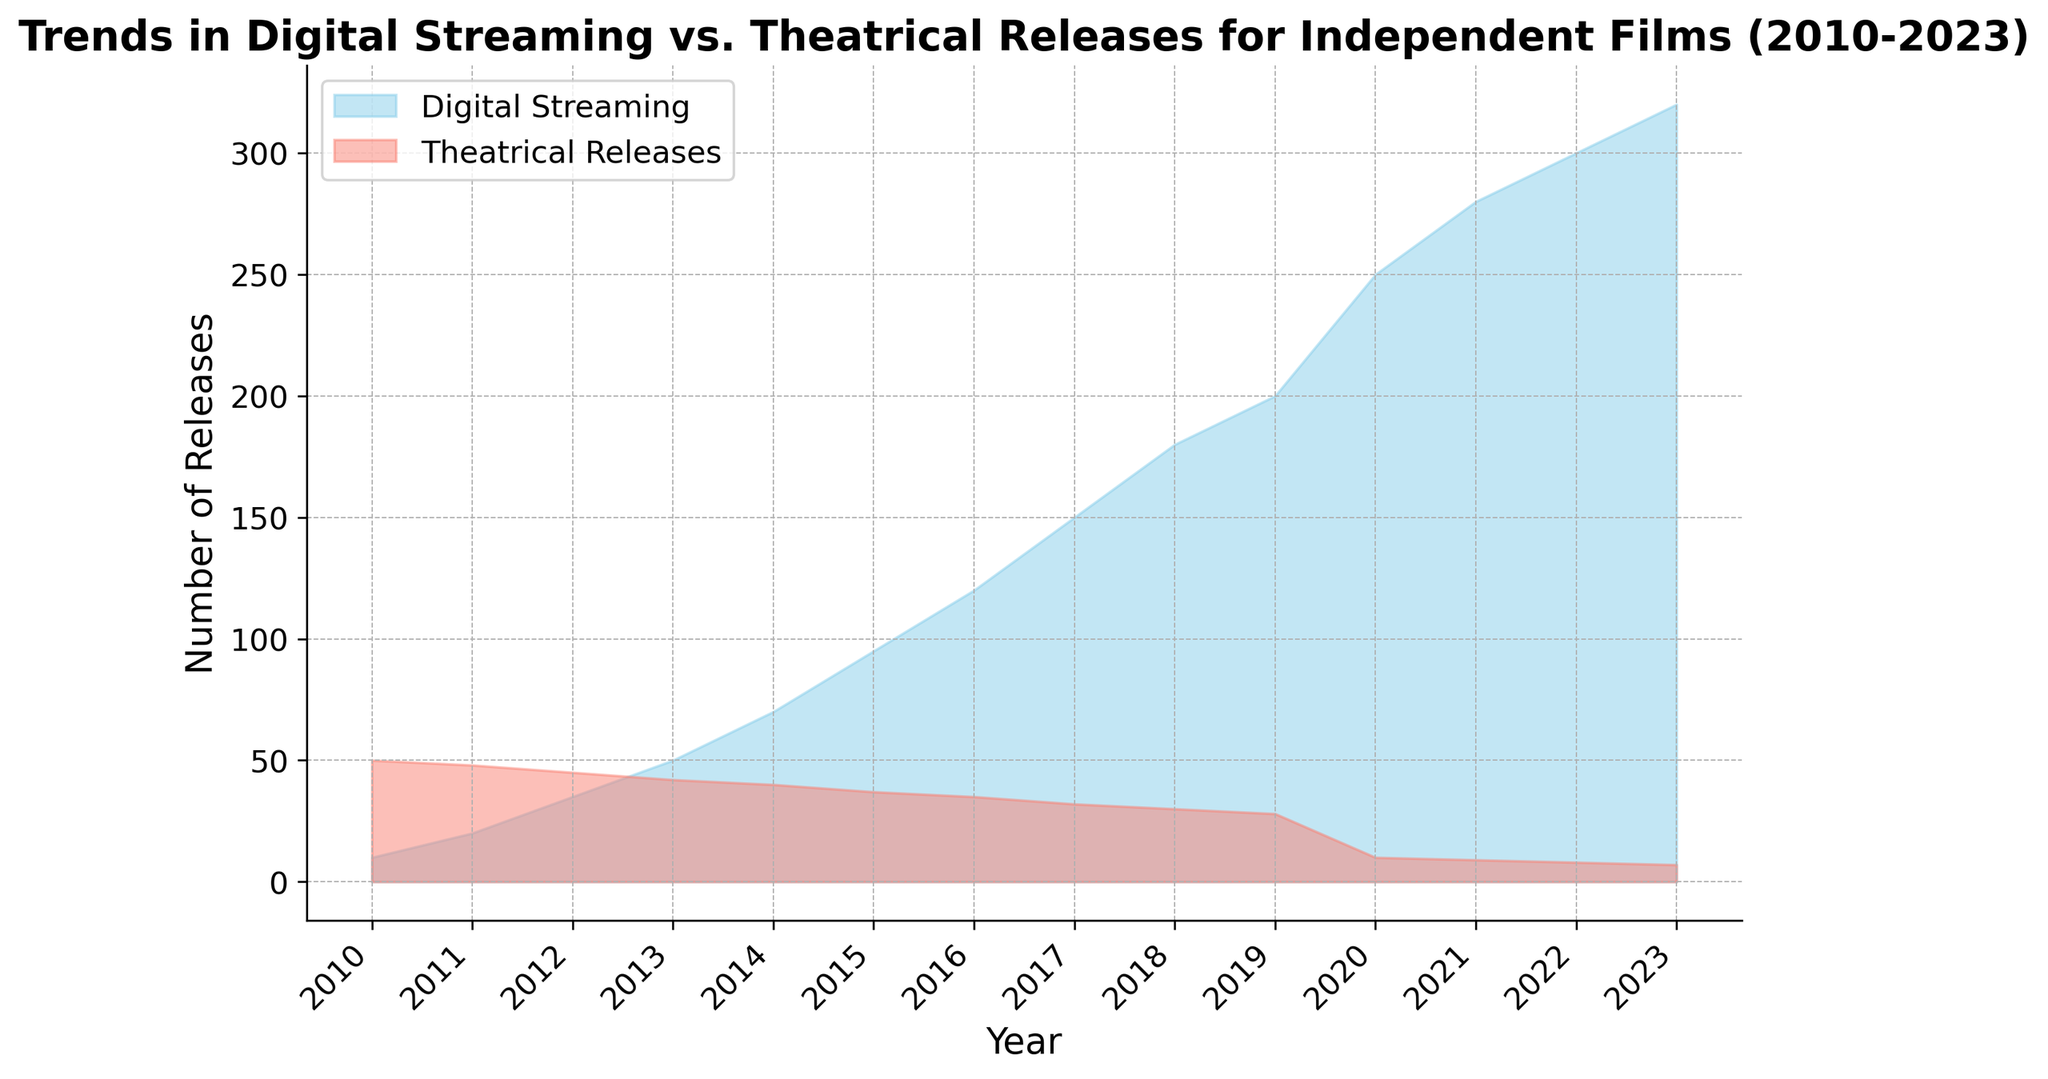What year saw the largest number of digital streaming releases? The year is seen where the blue area reaches its highest point. Observing the area chart, the largest number of digital streaming releases is at the topmost point of the blue area which occurs in 2023.
Answer: 2023 How did the number of theatrical releases change from 2010 to 2023? Observe the red area for theatrical releases starting from 2010 to 2023. Notice the trend as the red area decreases steadily over the years. Comparing the start and end values, theatrical releases decreased from 50 in 2010 to 7 in 2023.
Answer: Decreased Which year had approximately equal numbers of digital streaming and theatrical releases? Look for overlap points where the blue and red areas are nearly equal in height. This occurs where both areas visually converge. In 2013, both digital streaming and theatrical releases are around 42-45 releases.
Answer: 2013 How does the growth rate of digital streaming releases compare to theatrical releases over the entire period shown? Observe the slope of the respective areas. The blue area slope for digital streaming releases is steeper compared to the gradual slope of the red area for theatrical releases, indicating a rapid increase in digital streaming compared to a slow decrease in theatrical releases.
Answer: Digital streaming has grown faster What is the difference in the number of digital streaming releases between 2010 and 2023? Subtract the number of digital streaming releases in 2010 from that in 2023. The difference is 320 - 10.
Answer: 310 How much did the number of theatrical releases decrease from 2014 to 2020? Subtract the number of theatrical releases in 2020 from the number in 2014. The difference is 40 - 10.
Answer: 30 In which year did digital streaming releases surpass 100 for the first time? Identify the point where the blue area exceeds 100. This happens in 2016 where digital streaming releases are 120.
Answer: 2016 What is the combined total number of releases for both digital streaming and theatrical releases in the year 2019? Add the number of digital streaming releases and theatrical releases for 2019. The combined total is 200 + 28.
Answer: 228 Which year shows the smallest gap between digital streaming and theatrical releases? Find the year where the blue and red areas are closest to each other by looking for the smallest vertical distance between them. This is in 2012 where digital streaming is 35 and theatrical releases are 45, a gap of 10.
Answer: 2012 